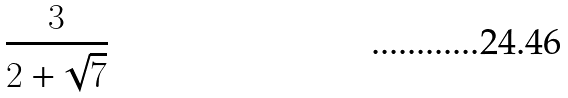<formula> <loc_0><loc_0><loc_500><loc_500>\frac { 3 } { 2 + \sqrt { 7 } }</formula> 